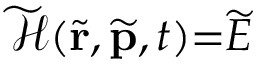<formula> <loc_0><loc_0><loc_500><loc_500>\widetilde { \mathcal { H } } ( \widetilde { r } , \widetilde { p } , t ) { = } \widetilde { E }</formula> 